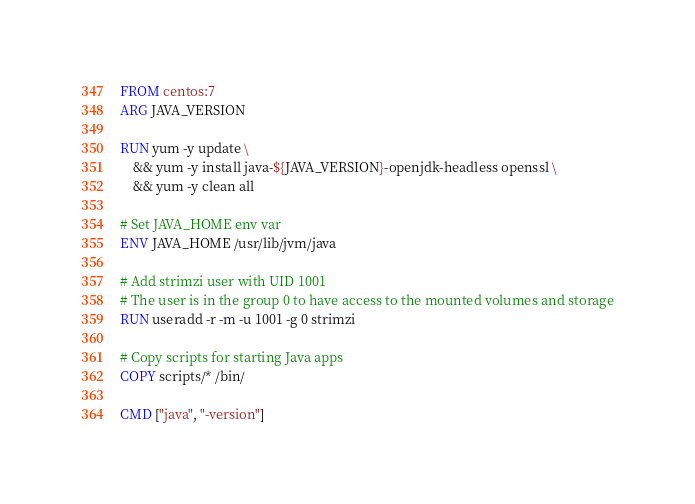<code> <loc_0><loc_0><loc_500><loc_500><_Dockerfile_>FROM centos:7
ARG JAVA_VERSION

RUN yum -y update \
    && yum -y install java-${JAVA_VERSION}-openjdk-headless openssl \
    && yum -y clean all

# Set JAVA_HOME env var
ENV JAVA_HOME /usr/lib/jvm/java

# Add strimzi user with UID 1001
# The user is in the group 0 to have access to the mounted volumes and storage
RUN useradd -r -m -u 1001 -g 0 strimzi

# Copy scripts for starting Java apps
COPY scripts/* /bin/

CMD ["java", "-version"]
</code> 